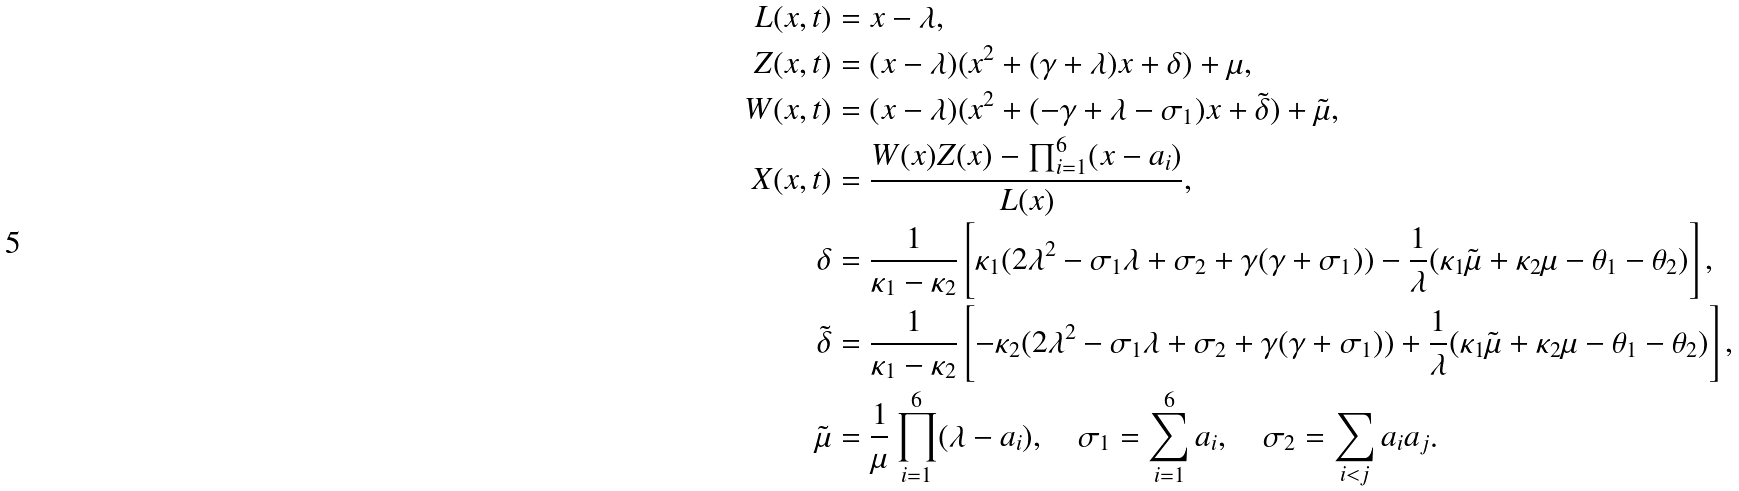<formula> <loc_0><loc_0><loc_500><loc_500>L ( x , t ) & = x - \lambda , \\ Z ( x , t ) & = ( x - \lambda ) ( x ^ { 2 } + ( \gamma + \lambda ) x + \delta ) + \mu , \\ W ( x , t ) & = ( x - \lambda ) ( x ^ { 2 } + ( - \gamma + \lambda - \sigma _ { 1 } ) x + \tilde { \delta } ) + \tilde { \mu } , \\ X ( x , t ) & = \frac { W ( x ) Z ( x ) - \prod _ { i = 1 } ^ { 6 } ( x - a _ { i } ) } { L ( x ) } , \\ \delta & = \frac { 1 } { \kappa _ { 1 } - \kappa _ { 2 } } \left [ \kappa _ { 1 } ( 2 \lambda ^ { 2 } - \sigma _ { 1 } \lambda + \sigma _ { 2 } + \gamma ( \gamma + \sigma _ { 1 } ) ) - \frac { 1 } { \lambda } ( \kappa _ { 1 } \tilde { \mu } + \kappa _ { 2 } \mu - \theta _ { 1 } - \theta _ { 2 } ) \right ] , \\ \tilde { \delta } & = \frac { 1 } { \kappa _ { 1 } - \kappa _ { 2 } } \left [ - \kappa _ { 2 } ( 2 \lambda ^ { 2 } - \sigma _ { 1 } \lambda + \sigma _ { 2 } + \gamma ( \gamma + \sigma _ { 1 } ) ) + \frac { 1 } { \lambda } ( \kappa _ { 1 } \tilde { \mu } + \kappa _ { 2 } \mu - \theta _ { 1 } - \theta _ { 2 } ) \right ] , \\ \tilde { \mu } & = \frac { 1 } { \mu } \prod _ { i = 1 } ^ { 6 } ( \lambda - a _ { i } ) , \quad \sigma _ { 1 } = \sum _ { i = 1 } ^ { 6 } a _ { i } , \quad \sigma _ { 2 } = \sum _ { i < j } a _ { i } a _ { j } .</formula> 